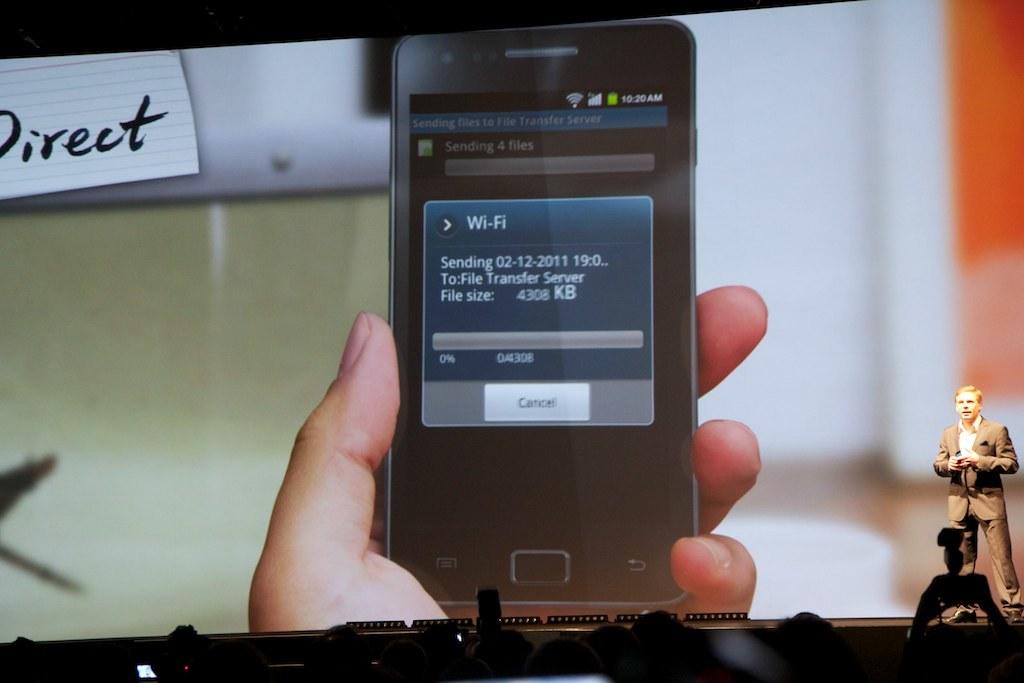What is the date of the file?
Your answer should be very brief. 02-12-2011. 